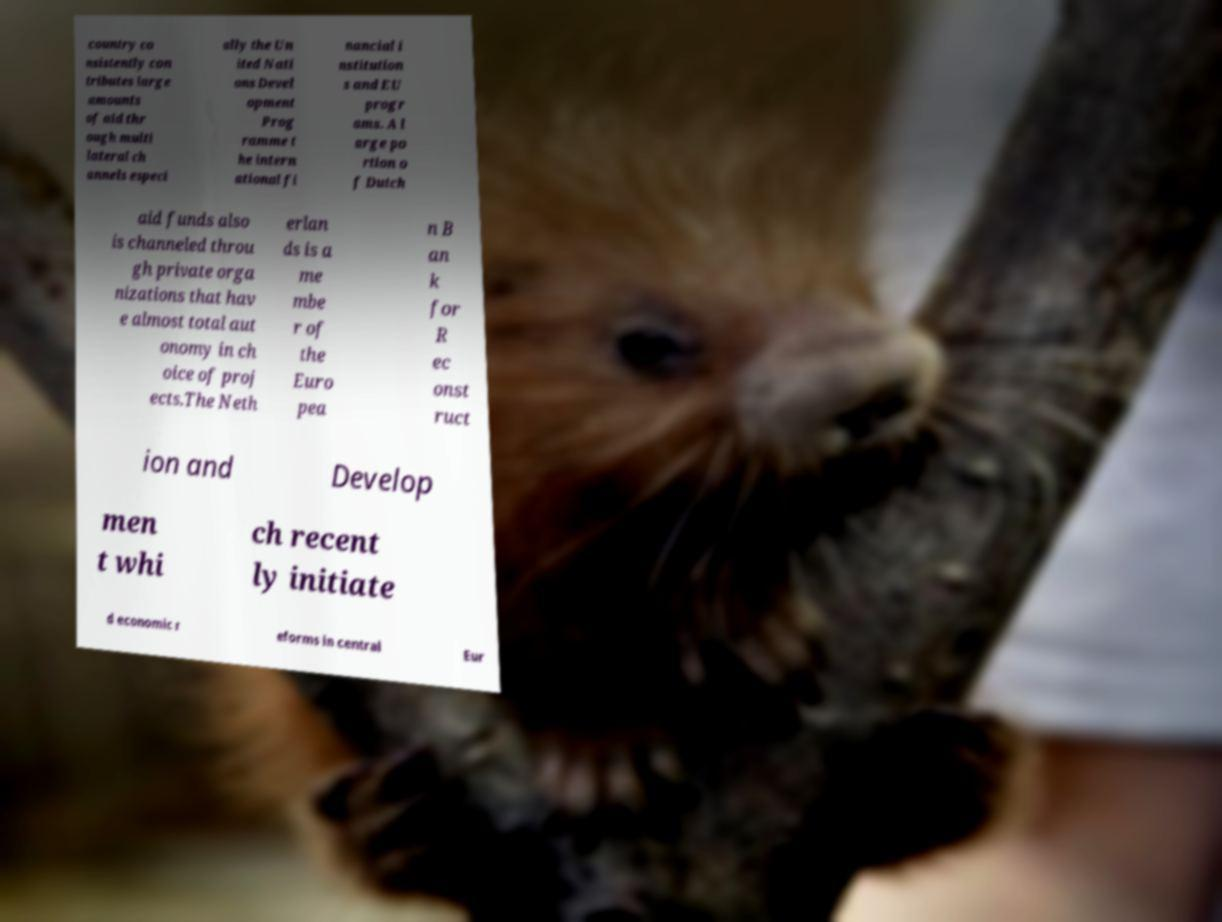Could you assist in decoding the text presented in this image and type it out clearly? country co nsistently con tributes large amounts of aid thr ough multi lateral ch annels especi ally the Un ited Nati ons Devel opment Prog ramme t he intern ational fi nancial i nstitution s and EU progr ams. A l arge po rtion o f Dutch aid funds also is channeled throu gh private orga nizations that hav e almost total aut onomy in ch oice of proj ects.The Neth erlan ds is a me mbe r of the Euro pea n B an k for R ec onst ruct ion and Develop men t whi ch recent ly initiate d economic r eforms in central Eur 